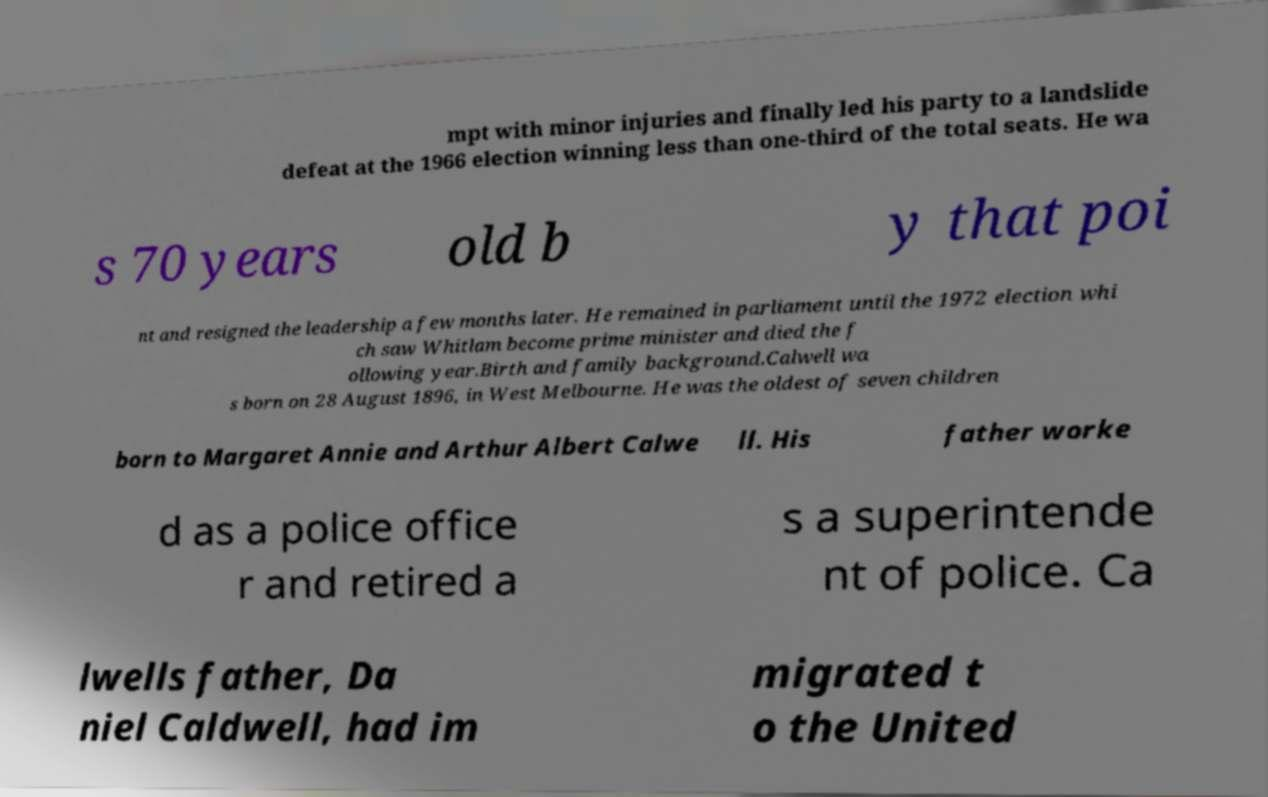There's text embedded in this image that I need extracted. Can you transcribe it verbatim? mpt with minor injuries and finally led his party to a landslide defeat at the 1966 election winning less than one-third of the total seats. He wa s 70 years old b y that poi nt and resigned the leadership a few months later. He remained in parliament until the 1972 election whi ch saw Whitlam become prime minister and died the f ollowing year.Birth and family background.Calwell wa s born on 28 August 1896, in West Melbourne. He was the oldest of seven children born to Margaret Annie and Arthur Albert Calwe ll. His father worke d as a police office r and retired a s a superintende nt of police. Ca lwells father, Da niel Caldwell, had im migrated t o the United 